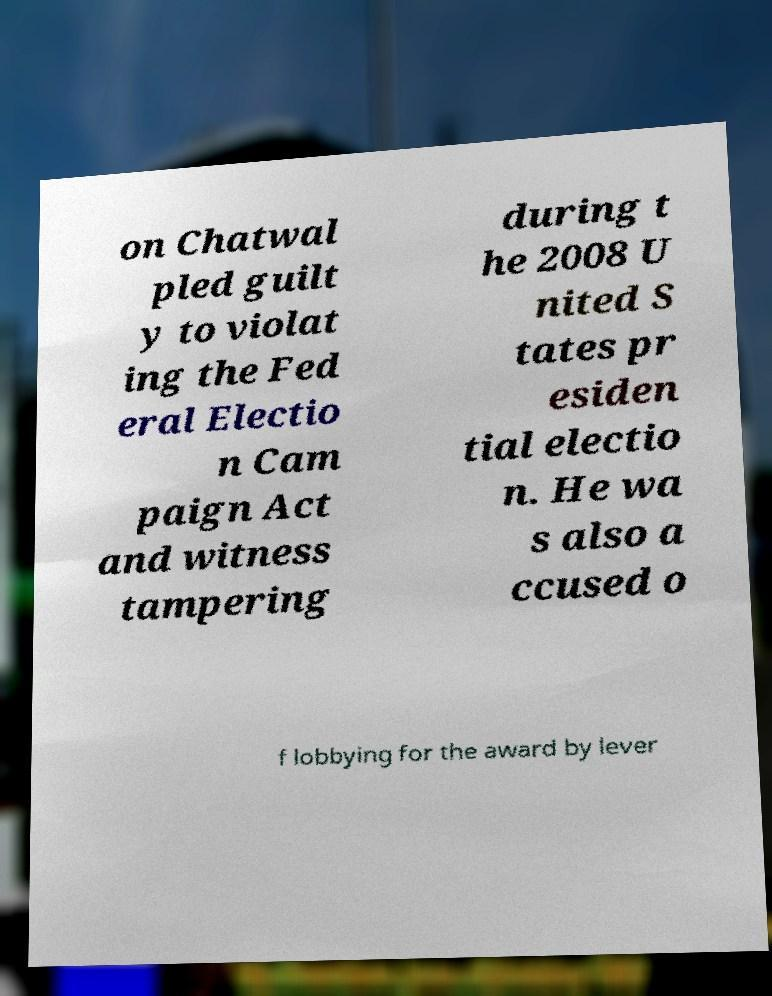There's text embedded in this image that I need extracted. Can you transcribe it verbatim? on Chatwal pled guilt y to violat ing the Fed eral Electio n Cam paign Act and witness tampering during t he 2008 U nited S tates pr esiden tial electio n. He wa s also a ccused o f lobbying for the award by lever 